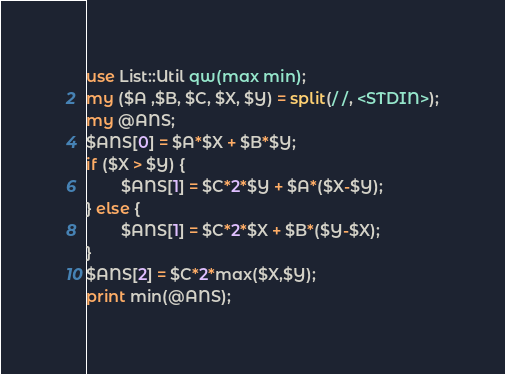Convert code to text. <code><loc_0><loc_0><loc_500><loc_500><_Perl_>use List::Util qw(max min);
my ($A ,$B, $C, $X, $Y) = split(/ /, <STDIN>);
my @ANS;
$ANS[0] = $A*$X + $B*$Y;
if ($X > $Y) {
        $ANS[1] = $C*2*$Y + $A*($X-$Y);
} else {
        $ANS[1] = $C*2*$X + $B*($Y-$X);
}
$ANS[2] = $C*2*max($X,$Y);
print min(@ANS);</code> 